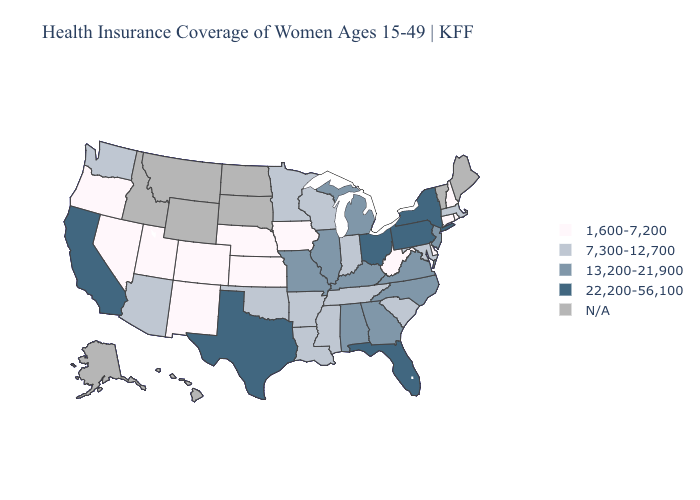Name the states that have a value in the range 22,200-56,100?
Be succinct. California, Florida, New York, Ohio, Pennsylvania, Texas. Does the map have missing data?
Answer briefly. Yes. Among the states that border Mississippi , does Louisiana have the highest value?
Be succinct. No. Among the states that border Kansas , does Colorado have the lowest value?
Keep it brief. Yes. Name the states that have a value in the range 7,300-12,700?
Write a very short answer. Arizona, Arkansas, Indiana, Louisiana, Maryland, Massachusetts, Minnesota, Mississippi, Oklahoma, South Carolina, Tennessee, Washington, Wisconsin. Name the states that have a value in the range 22,200-56,100?
Give a very brief answer. California, Florida, New York, Ohio, Pennsylvania, Texas. Name the states that have a value in the range N/A?
Concise answer only. Alaska, Hawaii, Idaho, Maine, Montana, North Dakota, South Dakota, Vermont, Wyoming. Among the states that border Nebraska , which have the lowest value?
Concise answer only. Colorado, Iowa, Kansas. Name the states that have a value in the range 7,300-12,700?
Quick response, please. Arizona, Arkansas, Indiana, Louisiana, Maryland, Massachusetts, Minnesota, Mississippi, Oklahoma, South Carolina, Tennessee, Washington, Wisconsin. How many symbols are there in the legend?
Quick response, please. 5. Name the states that have a value in the range 13,200-21,900?
Answer briefly. Alabama, Georgia, Illinois, Kentucky, Michigan, Missouri, New Jersey, North Carolina, Virginia. What is the value of North Carolina?
Write a very short answer. 13,200-21,900. Among the states that border Kansas , which have the highest value?
Short answer required. Missouri. Does New York have the highest value in the USA?
Write a very short answer. Yes. Does Texas have the highest value in the USA?
Concise answer only. Yes. 